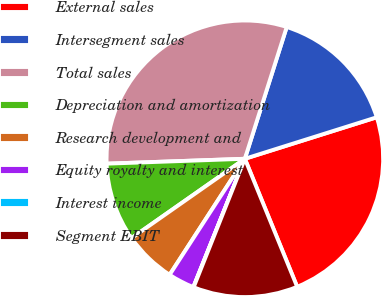<chart> <loc_0><loc_0><loc_500><loc_500><pie_chart><fcel>External sales<fcel>Intersegment sales<fcel>Total sales<fcel>Depreciation and amortization<fcel>Research development and<fcel>Equity royalty and interest<fcel>Interest income<fcel>Segment EBIT<nl><fcel>23.68%<fcel>15.25%<fcel>30.46%<fcel>9.16%<fcel>6.12%<fcel>3.08%<fcel>0.04%<fcel>12.21%<nl></chart> 